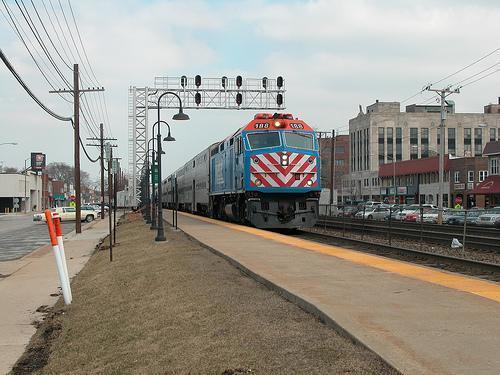How many trains?
Give a very brief answer. 1. 